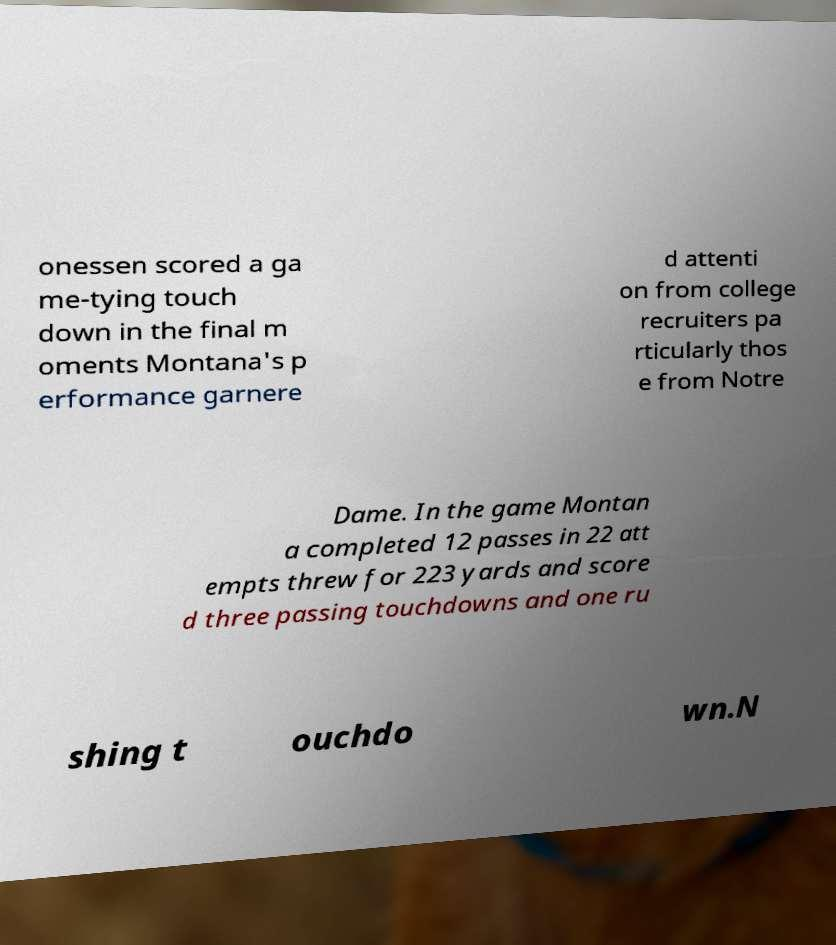For documentation purposes, I need the text within this image transcribed. Could you provide that? onessen scored a ga me-tying touch down in the final m oments Montana's p erformance garnere d attenti on from college recruiters pa rticularly thos e from Notre Dame. In the game Montan a completed 12 passes in 22 att empts threw for 223 yards and score d three passing touchdowns and one ru shing t ouchdo wn.N 